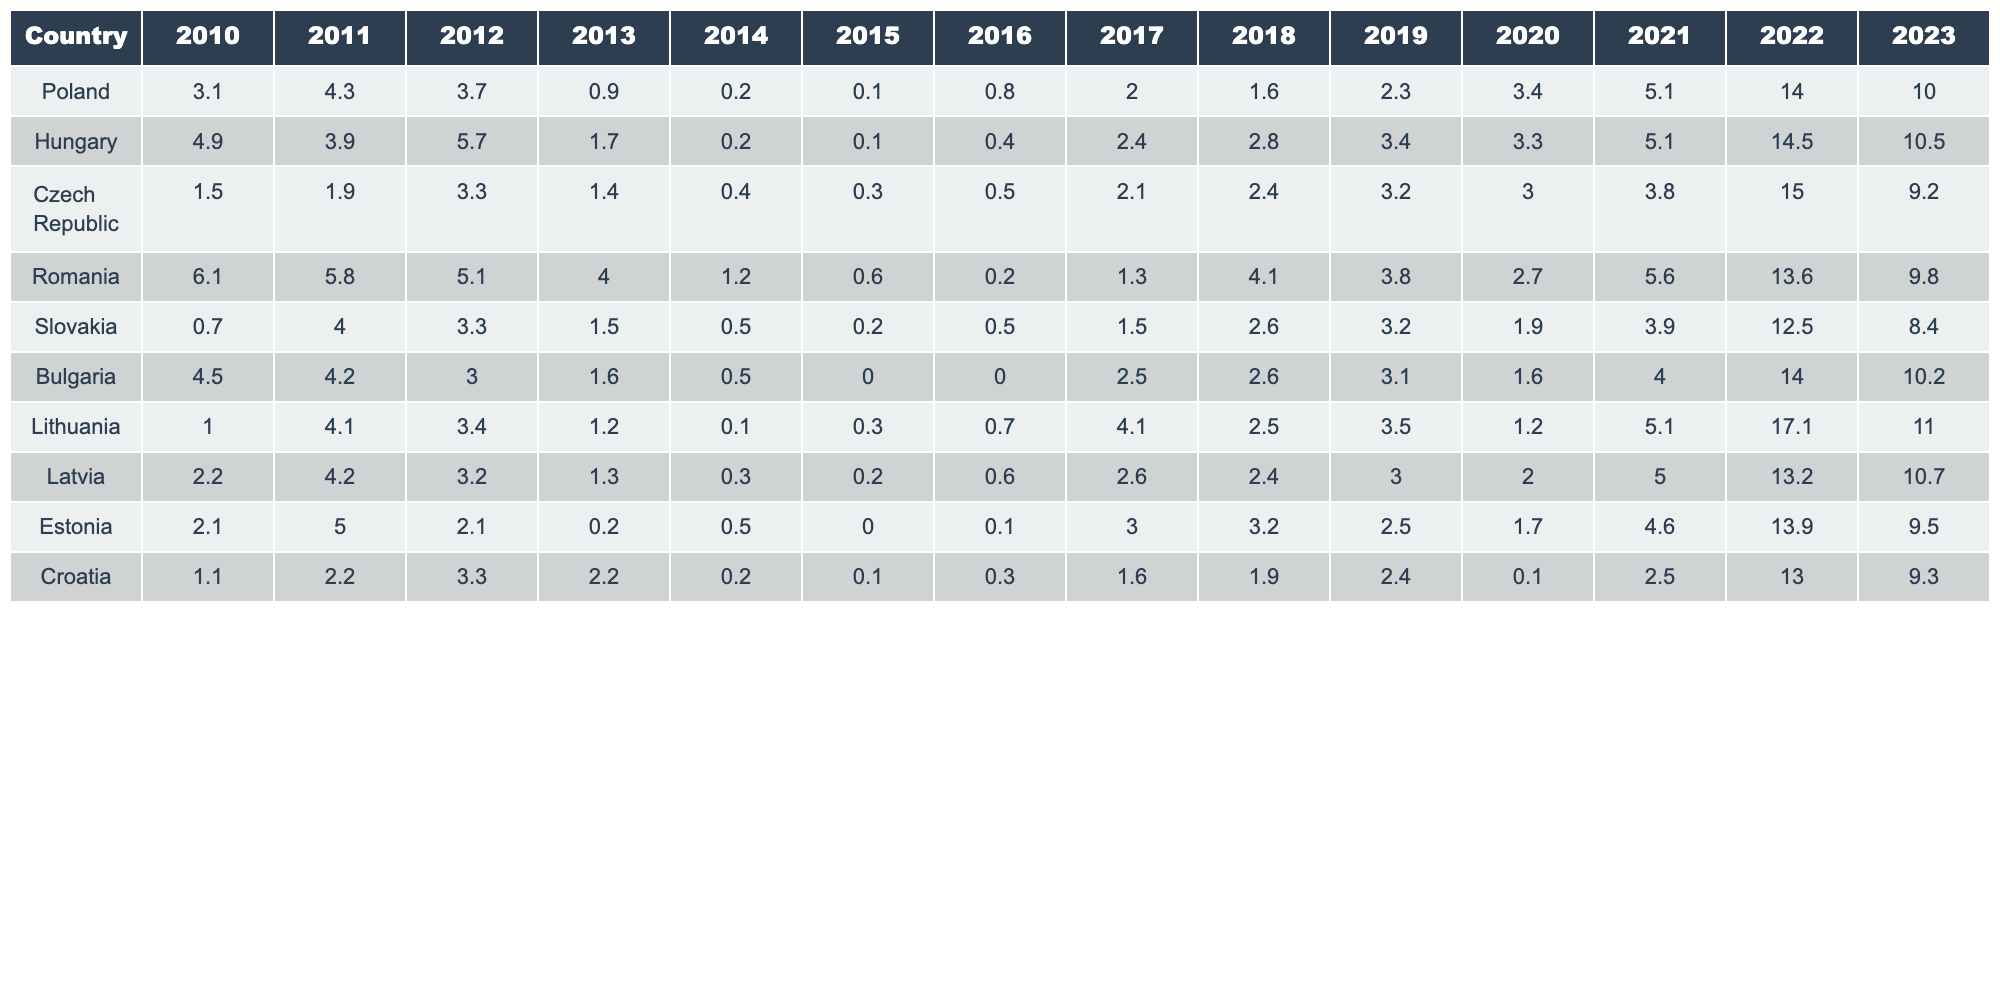What was the inflation rate in Hungary in 2022? The table shows that the inflation rate in Hungary for the year 2022 is 14.5%.
Answer: 14.5% Which country had the highest inflation rate in 2021? Referring to the table, I identify that the country with the highest inflation rate for 2021 is Lithuania with a rate of 17.1%.
Answer: Lithuania What is the average inflation rate for Poland from 2010 to 2023? The average can be calculated by summing the inflation rates from 2010 to 2023 for Poland, which totals (3.1 + 4.3 + 3.7 + 0.9 + 0.2 + 0.1 + 0.8 + 2.0 + 1.6 + 2.3 + 3.4 + 5.1 + 14.0 + 10.0) = 56.6. Dividing by the number of years (14), I get 56.6 / 14 = 4.04.
Answer: 4.04 Is the inflation rate in Estonia consistently lower than 3% from 2010 to 2019? I check the inflation rates for Estonia from 2010 to 2019 in the table. The rates are 2.1, 5.0, 2.1, 0.2, 0.5, 0.0, 0.1, 3.0, 3.2, and 2.5. Since there are entries (5.0, 3.0, 3.2) that exceed 3%, the answer is no.
Answer: No In which year did the Czech Republic experience its peak inflation rate? Looking at the table for the Czech Republic, I find that the peak inflation rate of 15.0% occurred in 2022.
Answer: 2022 Compare the average inflation rates of Romania and Slovakia from 2010 to 2023. First, I sum the inflation rates for Romania (6.1 + 5.8 + 5.1 + 4.0 + 1.2 + 0.6 + 0.2 + 1.3 + 4.1 + 3.8 + 2.7 + 5.6 + 13.6 + 9.8) = 56.4, and then divide by 14 to get an average of 4.03. For Slovakia, I sum (0.7 + 4.0 + 3.3 + 1.5 + 0.5 + 0.2 + 0.5 + 1.5 + 2.6 + 3.2 + 1.9 + 3.9 + 12.5 + 8.4) = 40.4, giving an average of 2.89. Comparing the two averages shows Romania has a higher average inflation rate at 4.03, compared to Slovakia's 2.89.
Answer: Romania has a higher average inflation rate Which country had the lowest inflation rate in 2010? The table indicates that Slovakia had the lowest inflation rate for 2010 at 0.7%.
Answer: Slovakia Was there any year between 2010 and 2023 where Latvia's inflation rate crossed 5%? By reviewing the table for Latvia, the rates are 2.2, 4.2, 3.2, 1.3, 0.3, 0.2, 0.6, 2.6, 2.4, 3.0, 2.0, 5.0, 13.2, and 10.7. The rates do not exceed 5% until 2022. Thus, there were years (2022 and 2023) where it crossed 5%.
Answer: Yes How did the inflation rate trend for Lithuania from 2010 to 2023? I extract the data for Lithuania: 1.0, 4.1, 3.4, 1.2, 0.1, 0.3, 0.7, 4.1, 2.5, 3.5, 1.2, 5.1, 17.1, 11.0. Initially, the rate was low, experienced a peak in 2022, and has reduced in 2023. Therefore, the trend shows a fluctuation with a peak in 2022.
Answer: Fluctuating with a peak in 2022 